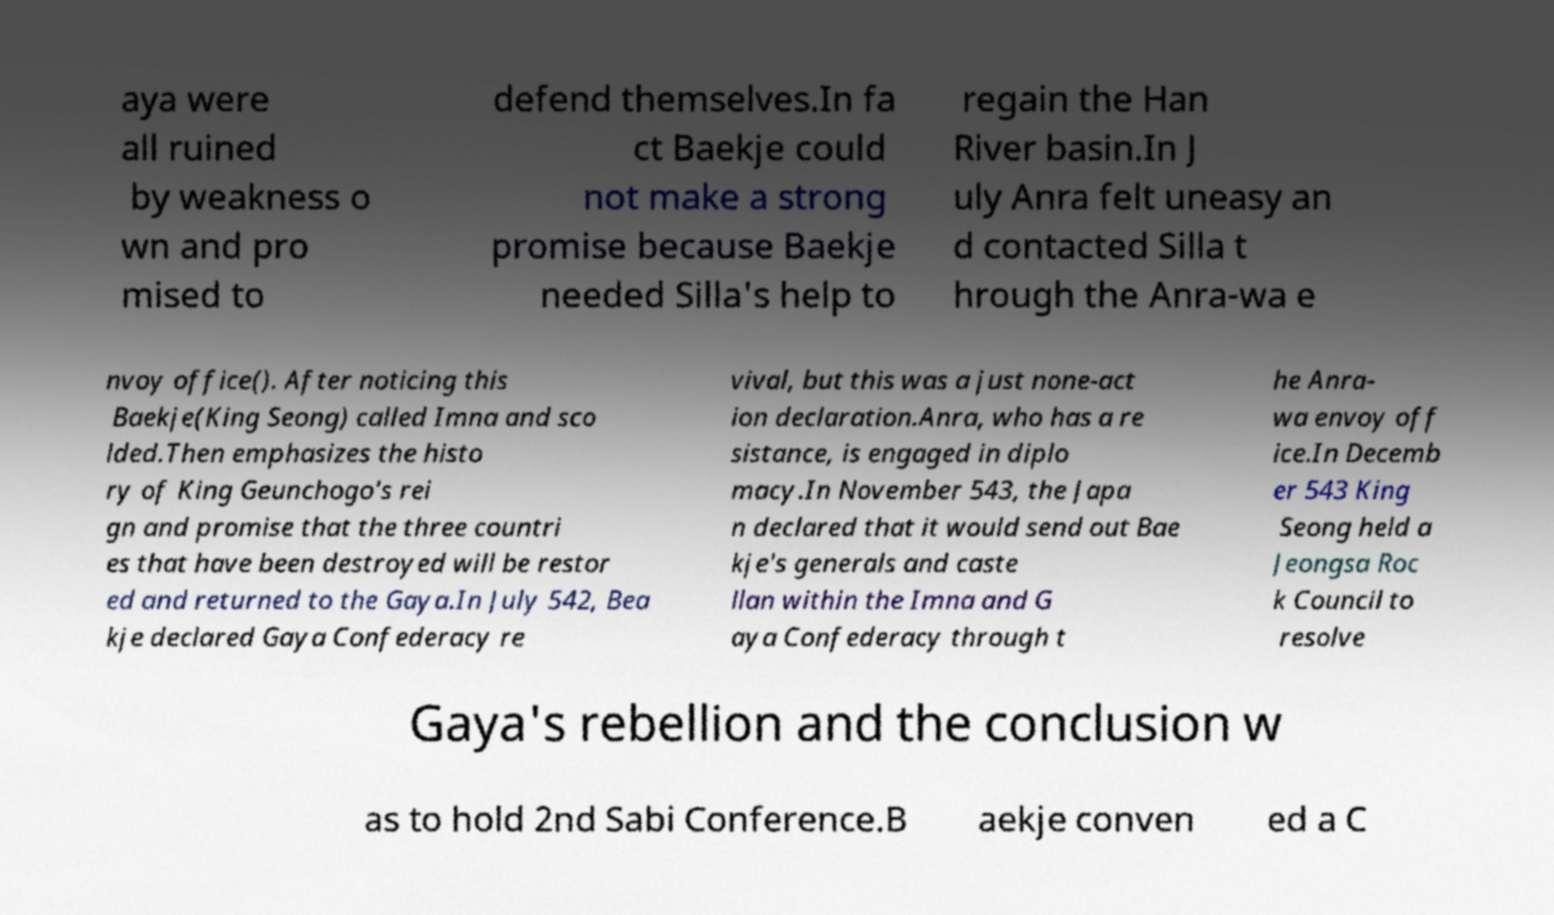Please identify and transcribe the text found in this image. aya were all ruined by weakness o wn and pro mised to defend themselves.In fa ct Baekje could not make a strong promise because Baekje needed Silla's help to regain the Han River basin.In J uly Anra felt uneasy an d contacted Silla t hrough the Anra-wa e nvoy office(). After noticing this Baekje(King Seong) called Imna and sco lded.Then emphasizes the histo ry of King Geunchogo's rei gn and promise that the three countri es that have been destroyed will be restor ed and returned to the Gaya.In July 542, Bea kje declared Gaya Confederacy re vival, but this was a just none-act ion declaration.Anra, who has a re sistance, is engaged in diplo macy.In November 543, the Japa n declared that it would send out Bae kje's generals and caste llan within the Imna and G aya Confederacy through t he Anra- wa envoy off ice.In Decemb er 543 King Seong held a Jeongsa Roc k Council to resolve Gaya's rebellion and the conclusion w as to hold 2nd Sabi Conference.B aekje conven ed a C 